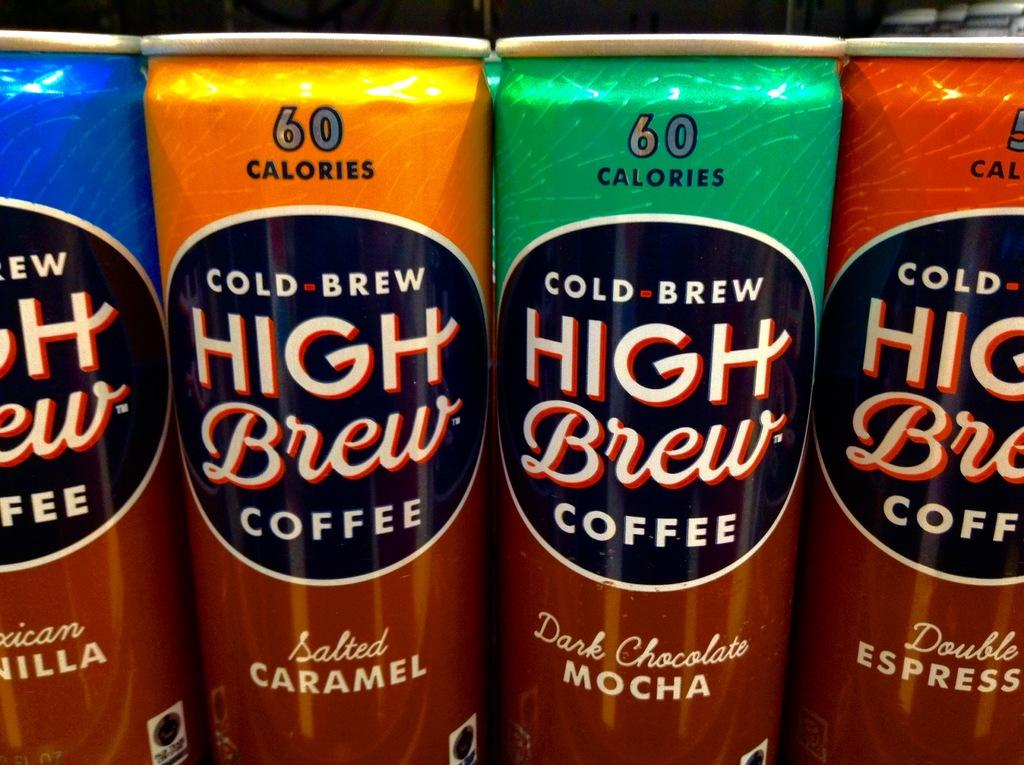Provide a one-sentence caption for the provided image. A close up of four cans of low calorie coffee of various flavours. 